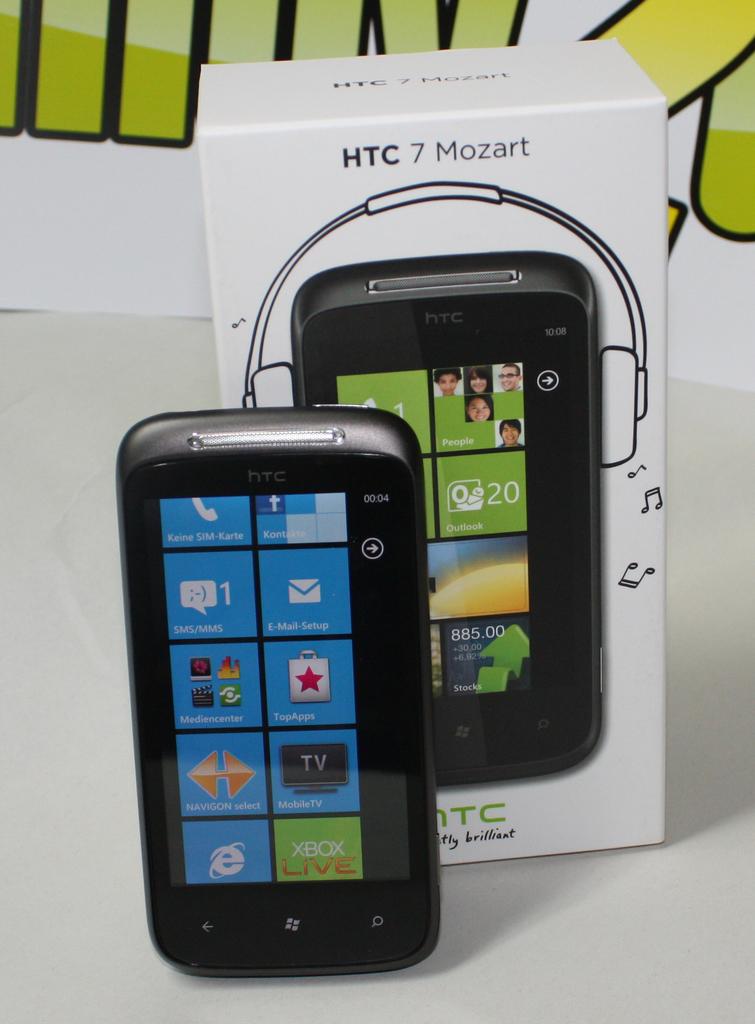What is the brand of the phone?
Give a very brief answer. Htc. What app is in the green square?
Your response must be concise. Xbox live. 